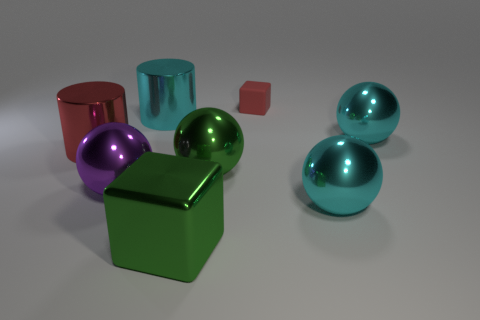Subtract all green spheres. How many spheres are left? 3 Subtract all purple metallic balls. How many balls are left? 3 Subtract 2 balls. How many balls are left? 2 Add 1 large purple objects. How many objects exist? 9 Subtract all gray spheres. Subtract all blue cylinders. How many spheres are left? 4 Subtract all cylinders. How many objects are left? 6 Add 7 blue objects. How many blue objects exist? 7 Subtract 0 purple blocks. How many objects are left? 8 Subtract all large cubes. Subtract all big green blocks. How many objects are left? 6 Add 5 big red objects. How many big red objects are left? 6 